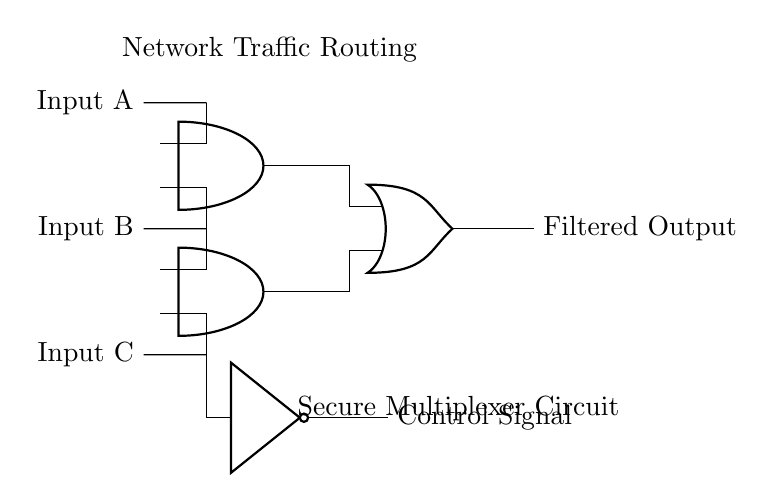What are the input signals in the circuit? The input signals are labeled as Input A, Input B, and Input C, which are marked clearly on the left side of the circuit diagram.
Answer: Input A, Input B, Input C How many AND gates are present in the circuit? There are two AND gates present in the circuit, indicated by the symbols and their respective placement in the diagram.
Answer: Two What does the output of the OR gate represent? The output of the OR gate represents the "Filtered Output," as labeled on the right side of the circuit.
Answer: Filtered Output What kind of function does the NOT gate provide in this circuit? The NOT gate inverts the signal coming from Input C, and its output is labeled as "Control Signal," indicating its controlling function within the circuit's operation.
Answer: Inversion Why would one use a multiplexer circuit in a secure environment? A multiplexer circuit routes and filters network traffic, allowing only selected connections to be established, which enhances security by controlling which signals are allowed through, effectively filtering unwanted data.
Answer: Routing and filtering What is the purpose of connecting Input C to the NOT gate? Connecting Input C to the NOT gate allows the inverted signal of Input C to be used as a control signal, which can help manage which paths the data can follow in the multiplexer circuit.
Answer: Control signal generation 